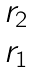Convert formula to latex. <formula><loc_0><loc_0><loc_500><loc_500>\begin{matrix} r _ { 2 } \\ r _ { 1 } \end{matrix}</formula> 